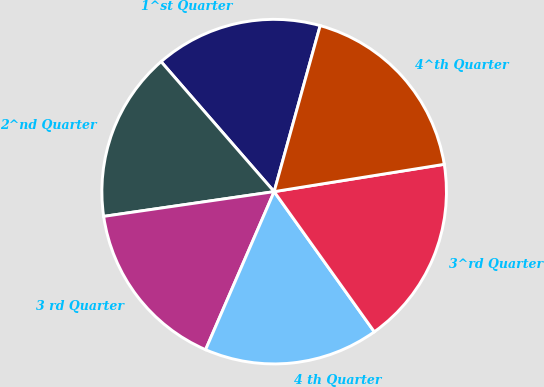Convert chart to OTSL. <chart><loc_0><loc_0><loc_500><loc_500><pie_chart><fcel>1^st Quarter<fcel>2^nd Quarter<fcel>3 rd Quarter<fcel>4 th Quarter<fcel>3^rd Quarter<fcel>4^th Quarter<nl><fcel>15.7%<fcel>15.9%<fcel>16.19%<fcel>16.39%<fcel>17.66%<fcel>18.16%<nl></chart> 